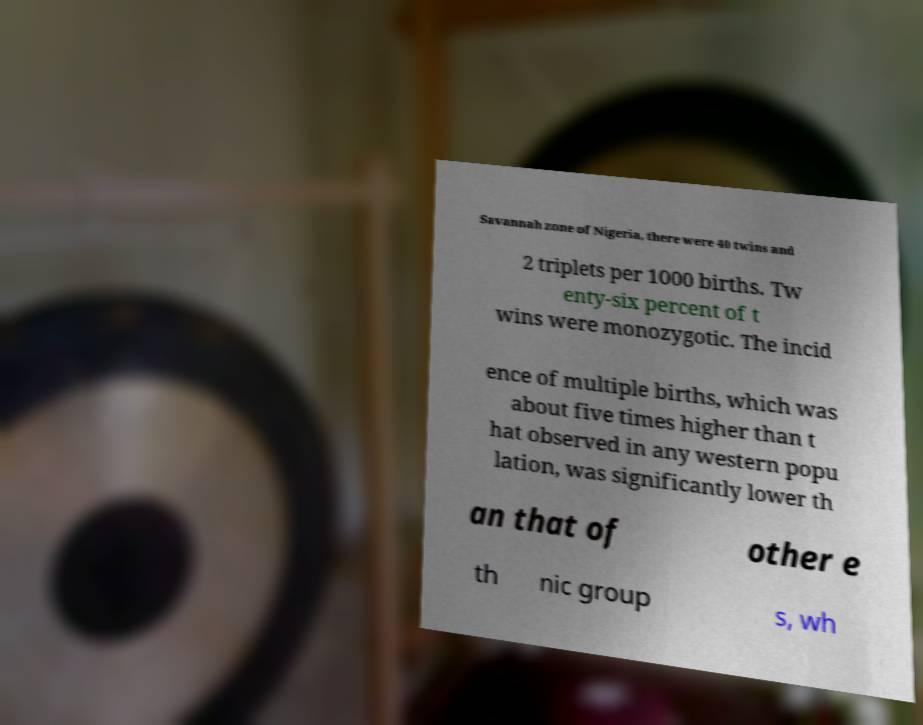Please read and relay the text visible in this image. What does it say? Savannah zone of Nigeria, there were 40 twins and 2 triplets per 1000 births. Tw enty-six percent of t wins were monozygotic. The incid ence of multiple births, which was about five times higher than t hat observed in any western popu lation, was significantly lower th an that of other e th nic group s, wh 